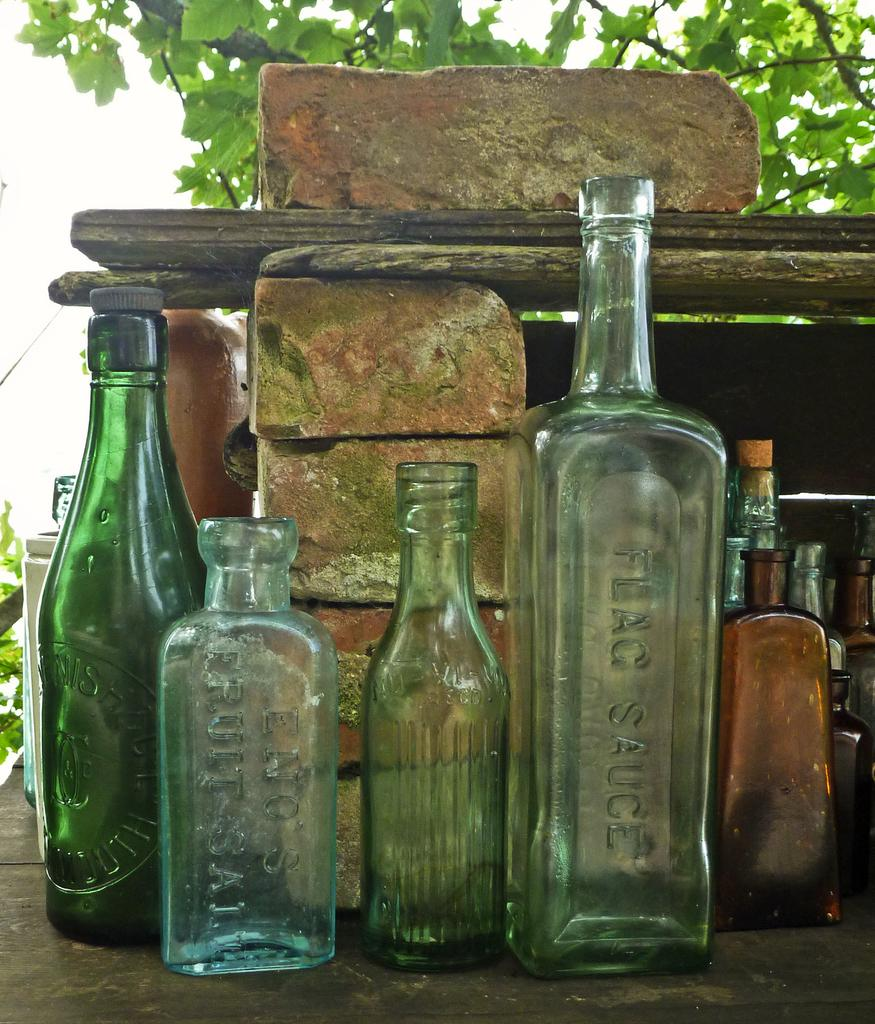What objects are visible in the image? There are empty glass bottles in the image. What is the bottles placed in front of? The bottles are placed in front of bricks. What is placed above the bricks? There is a log placed above the bricks. What can be seen in the background of the image? There is a tree visible behind the bottles. What type of note is attached to the log in the image? There is no note attached to the log in the image. What color are the trousers worn by the tree in the image? Trees do not wear trousers, and there is no person or object in the image that wears trousers. 